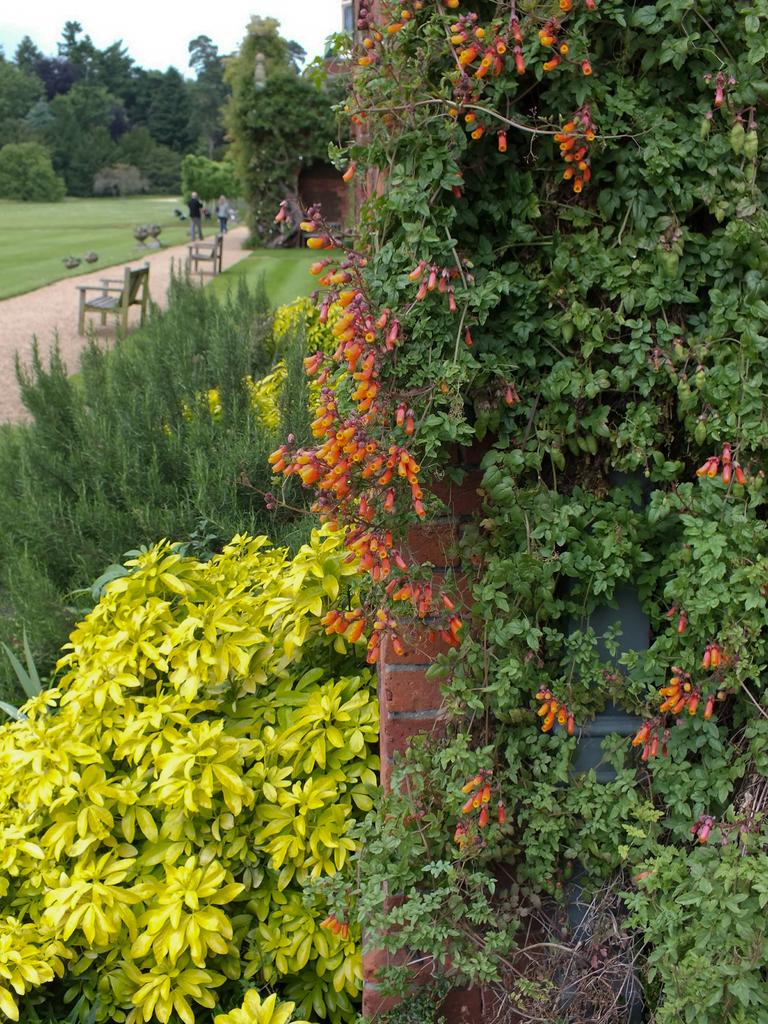What type of vegetation can be seen in the image? There are trees and bushes in the image. How many benches are present in the image? There are two benches in the image. What is the person in the image doing? There is a person standing in the image. What type of ground surface is visible in the image? There is grass in the image. Are there any flowers visible in the image? Yes, there are flowers on a tree in the image. What type of structure can be seen in the image? There is a wall in the image. What type of apparatus is being used by the person to turn the wall into a different color? There is no apparatus or indication of the person changing the color of the wall in the image. 